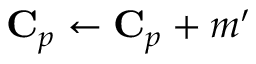Convert formula to latex. <formula><loc_0><loc_0><loc_500><loc_500>C _ { p } \gets C _ { p } + m ^ { \prime }</formula> 